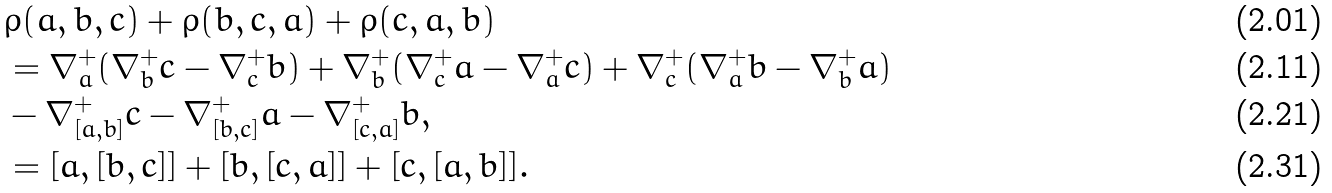<formula> <loc_0><loc_0><loc_500><loc_500>& \rho ( a , b , c ) + \rho ( b , c , a ) + \rho ( c , a , b ) \\ & = \nabla _ { a } ^ { + } ( \nabla _ { b } ^ { + } c - \nabla _ { c } ^ { + } b ) + \nabla _ { b } ^ { + } ( \nabla _ { c } ^ { + } a - \nabla _ { a } ^ { + } c ) + \nabla _ { c } ^ { + } ( \nabla _ { a } ^ { + } b - \nabla _ { b } ^ { + } a ) \\ & - \nabla _ { [ a , b ] } ^ { + } c - \nabla _ { [ b , c ] } ^ { + } a - \nabla _ { [ c , a ] } ^ { + } b , \\ & = [ a , [ b , c ] ] + [ b , [ c , a ] ] + [ c , [ a , b ] ] .</formula> 